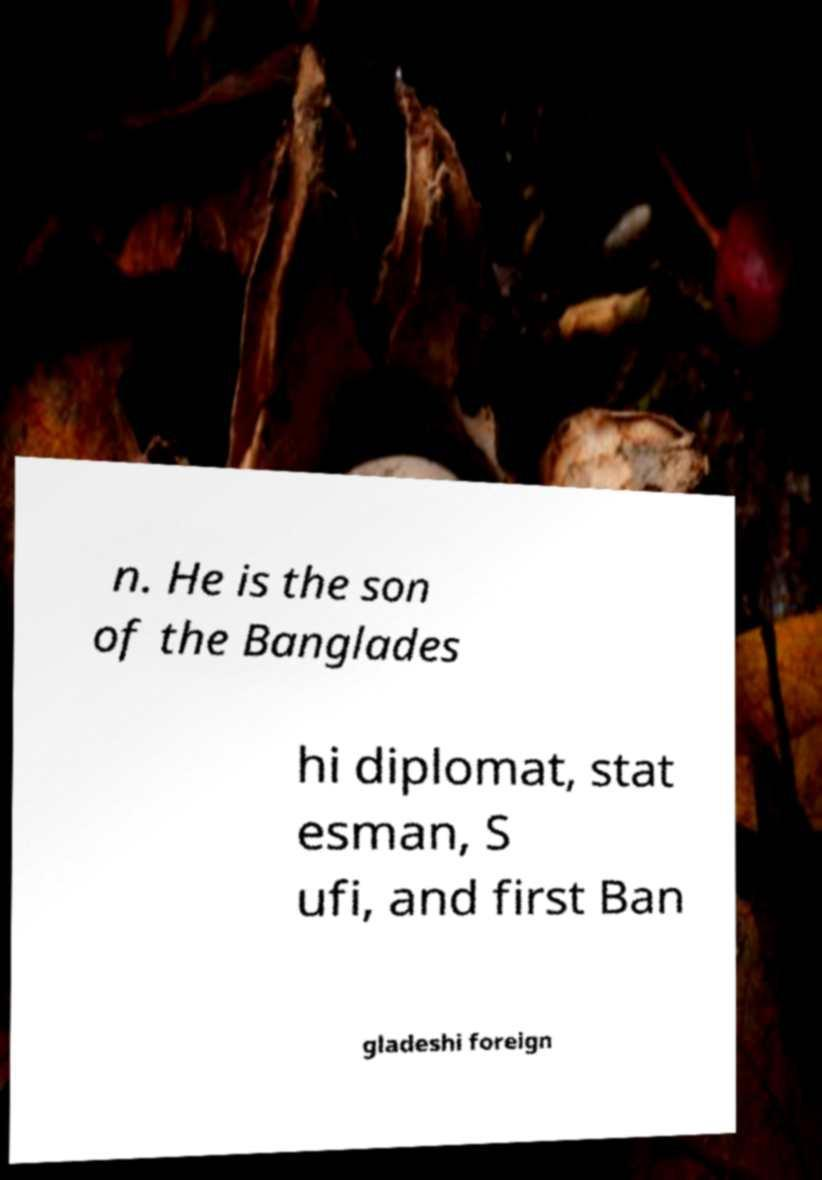Can you accurately transcribe the text from the provided image for me? n. He is the son of the Banglades hi diplomat, stat esman, S ufi, and first Ban gladeshi foreign 